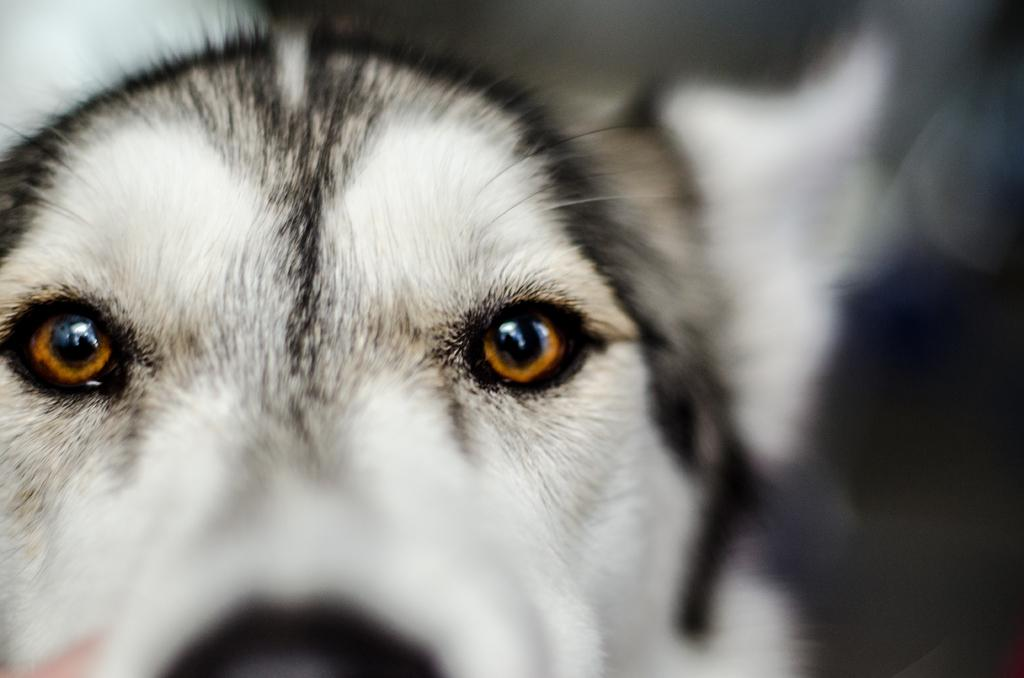What is the main subject of the image? The main subject of the image is a dog's face. Can you describe the background of the image? The background of the image is blurry. What type of wool is being stored in the drawer in the image? There is no drawer or wool present in the image; it features a dog's face with a blurry background. Where is the seat located in the image? There is no seat present in the image; it features a dog's face with a blurry background. 